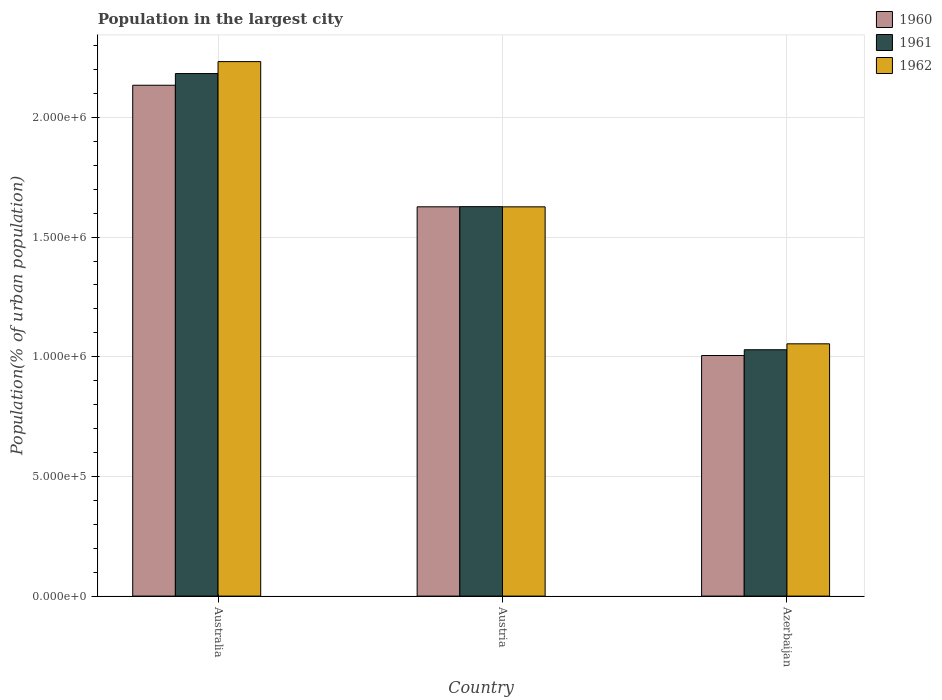Are the number of bars on each tick of the X-axis equal?
Make the answer very short. Yes. How many bars are there on the 3rd tick from the left?
Your answer should be compact. 3. How many bars are there on the 1st tick from the right?
Ensure brevity in your answer.  3. What is the label of the 2nd group of bars from the left?
Offer a terse response. Austria. In how many cases, is the number of bars for a given country not equal to the number of legend labels?
Give a very brief answer. 0. What is the population in the largest city in 1960 in Australia?
Your answer should be very brief. 2.13e+06. Across all countries, what is the maximum population in the largest city in 1962?
Your answer should be compact. 2.23e+06. Across all countries, what is the minimum population in the largest city in 1961?
Ensure brevity in your answer.  1.03e+06. In which country was the population in the largest city in 1961 maximum?
Provide a short and direct response. Australia. In which country was the population in the largest city in 1962 minimum?
Make the answer very short. Azerbaijan. What is the total population in the largest city in 1961 in the graph?
Your answer should be compact. 4.84e+06. What is the difference between the population in the largest city in 1962 in Australia and that in Azerbaijan?
Offer a very short reply. 1.18e+06. What is the difference between the population in the largest city in 1961 in Austria and the population in the largest city in 1962 in Azerbaijan?
Provide a short and direct response. 5.73e+05. What is the average population in the largest city in 1960 per country?
Offer a very short reply. 1.59e+06. What is the difference between the population in the largest city of/in 1960 and population in the largest city of/in 1962 in Azerbaijan?
Offer a terse response. -4.89e+04. What is the ratio of the population in the largest city in 1961 in Australia to that in Austria?
Make the answer very short. 1.34. Is the difference between the population in the largest city in 1960 in Australia and Azerbaijan greater than the difference between the population in the largest city in 1962 in Australia and Azerbaijan?
Give a very brief answer. No. What is the difference between the highest and the second highest population in the largest city in 1961?
Make the answer very short. -5.98e+05. What is the difference between the highest and the lowest population in the largest city in 1962?
Keep it short and to the point. 1.18e+06. In how many countries, is the population in the largest city in 1962 greater than the average population in the largest city in 1962 taken over all countries?
Give a very brief answer. 1. What does the 3rd bar from the left in Azerbaijan represents?
Your answer should be compact. 1962. What does the 1st bar from the right in Austria represents?
Ensure brevity in your answer.  1962. Is it the case that in every country, the sum of the population in the largest city in 1962 and population in the largest city in 1960 is greater than the population in the largest city in 1961?
Offer a very short reply. Yes. Are the values on the major ticks of Y-axis written in scientific E-notation?
Ensure brevity in your answer.  Yes. Does the graph contain any zero values?
Your answer should be very brief. No. Where does the legend appear in the graph?
Offer a terse response. Top right. How many legend labels are there?
Offer a terse response. 3. How are the legend labels stacked?
Provide a short and direct response. Vertical. What is the title of the graph?
Offer a terse response. Population in the largest city. What is the label or title of the X-axis?
Ensure brevity in your answer.  Country. What is the label or title of the Y-axis?
Your answer should be compact. Population(% of urban population). What is the Population(% of urban population) of 1960 in Australia?
Ensure brevity in your answer.  2.13e+06. What is the Population(% of urban population) of 1961 in Australia?
Your response must be concise. 2.18e+06. What is the Population(% of urban population) of 1962 in Australia?
Your answer should be compact. 2.23e+06. What is the Population(% of urban population) in 1960 in Austria?
Offer a very short reply. 1.63e+06. What is the Population(% of urban population) of 1961 in Austria?
Your answer should be compact. 1.63e+06. What is the Population(% of urban population) in 1962 in Austria?
Provide a succinct answer. 1.63e+06. What is the Population(% of urban population) of 1960 in Azerbaijan?
Your answer should be compact. 1.01e+06. What is the Population(% of urban population) of 1961 in Azerbaijan?
Ensure brevity in your answer.  1.03e+06. What is the Population(% of urban population) of 1962 in Azerbaijan?
Provide a short and direct response. 1.05e+06. Across all countries, what is the maximum Population(% of urban population) of 1960?
Offer a terse response. 2.13e+06. Across all countries, what is the maximum Population(% of urban population) of 1961?
Offer a terse response. 2.18e+06. Across all countries, what is the maximum Population(% of urban population) of 1962?
Your response must be concise. 2.23e+06. Across all countries, what is the minimum Population(% of urban population) in 1960?
Make the answer very short. 1.01e+06. Across all countries, what is the minimum Population(% of urban population) in 1961?
Offer a very short reply. 1.03e+06. Across all countries, what is the minimum Population(% of urban population) of 1962?
Ensure brevity in your answer.  1.05e+06. What is the total Population(% of urban population) of 1960 in the graph?
Keep it short and to the point. 4.77e+06. What is the total Population(% of urban population) of 1961 in the graph?
Provide a short and direct response. 4.84e+06. What is the total Population(% of urban population) of 1962 in the graph?
Offer a terse response. 4.91e+06. What is the difference between the Population(% of urban population) of 1960 in Australia and that in Austria?
Your answer should be very brief. 5.08e+05. What is the difference between the Population(% of urban population) in 1961 in Australia and that in Austria?
Keep it short and to the point. 5.56e+05. What is the difference between the Population(% of urban population) of 1962 in Australia and that in Austria?
Provide a succinct answer. 6.07e+05. What is the difference between the Population(% of urban population) in 1960 in Australia and that in Azerbaijan?
Give a very brief answer. 1.13e+06. What is the difference between the Population(% of urban population) of 1961 in Australia and that in Azerbaijan?
Your answer should be very brief. 1.15e+06. What is the difference between the Population(% of urban population) of 1962 in Australia and that in Azerbaijan?
Give a very brief answer. 1.18e+06. What is the difference between the Population(% of urban population) of 1960 in Austria and that in Azerbaijan?
Offer a terse response. 6.21e+05. What is the difference between the Population(% of urban population) in 1961 in Austria and that in Azerbaijan?
Offer a very short reply. 5.98e+05. What is the difference between the Population(% of urban population) of 1962 in Austria and that in Azerbaijan?
Your answer should be very brief. 5.72e+05. What is the difference between the Population(% of urban population) of 1960 in Australia and the Population(% of urban population) of 1961 in Austria?
Your answer should be compact. 5.07e+05. What is the difference between the Population(% of urban population) of 1960 in Australia and the Population(% of urban population) of 1962 in Austria?
Your response must be concise. 5.08e+05. What is the difference between the Population(% of urban population) of 1961 in Australia and the Population(% of urban population) of 1962 in Austria?
Provide a short and direct response. 5.57e+05. What is the difference between the Population(% of urban population) in 1960 in Australia and the Population(% of urban population) in 1961 in Azerbaijan?
Offer a terse response. 1.11e+06. What is the difference between the Population(% of urban population) in 1960 in Australia and the Population(% of urban population) in 1962 in Azerbaijan?
Offer a terse response. 1.08e+06. What is the difference between the Population(% of urban population) in 1961 in Australia and the Population(% of urban population) in 1962 in Azerbaijan?
Ensure brevity in your answer.  1.13e+06. What is the difference between the Population(% of urban population) in 1960 in Austria and the Population(% of urban population) in 1961 in Azerbaijan?
Offer a terse response. 5.97e+05. What is the difference between the Population(% of urban population) of 1960 in Austria and the Population(% of urban population) of 1962 in Azerbaijan?
Ensure brevity in your answer.  5.73e+05. What is the difference between the Population(% of urban population) in 1961 in Austria and the Population(% of urban population) in 1962 in Azerbaijan?
Make the answer very short. 5.73e+05. What is the average Population(% of urban population) of 1960 per country?
Offer a terse response. 1.59e+06. What is the average Population(% of urban population) of 1961 per country?
Make the answer very short. 1.61e+06. What is the average Population(% of urban population) in 1962 per country?
Provide a short and direct response. 1.64e+06. What is the difference between the Population(% of urban population) of 1960 and Population(% of urban population) of 1961 in Australia?
Keep it short and to the point. -4.88e+04. What is the difference between the Population(% of urban population) in 1960 and Population(% of urban population) in 1962 in Australia?
Offer a very short reply. -9.88e+04. What is the difference between the Population(% of urban population) of 1961 and Population(% of urban population) of 1962 in Australia?
Make the answer very short. -4.99e+04. What is the difference between the Population(% of urban population) in 1960 and Population(% of urban population) in 1961 in Austria?
Make the answer very short. -630. What is the difference between the Population(% of urban population) of 1960 and Population(% of urban population) of 1962 in Austria?
Offer a terse response. 129. What is the difference between the Population(% of urban population) of 1961 and Population(% of urban population) of 1962 in Austria?
Your answer should be very brief. 759. What is the difference between the Population(% of urban population) in 1960 and Population(% of urban population) in 1961 in Azerbaijan?
Provide a short and direct response. -2.41e+04. What is the difference between the Population(% of urban population) in 1960 and Population(% of urban population) in 1962 in Azerbaijan?
Your answer should be very brief. -4.89e+04. What is the difference between the Population(% of urban population) in 1961 and Population(% of urban population) in 1962 in Azerbaijan?
Offer a terse response. -2.47e+04. What is the ratio of the Population(% of urban population) in 1960 in Australia to that in Austria?
Give a very brief answer. 1.31. What is the ratio of the Population(% of urban population) in 1961 in Australia to that in Austria?
Offer a very short reply. 1.34. What is the ratio of the Population(% of urban population) of 1962 in Australia to that in Austria?
Make the answer very short. 1.37. What is the ratio of the Population(% of urban population) in 1960 in Australia to that in Azerbaijan?
Your answer should be compact. 2.12. What is the ratio of the Population(% of urban population) in 1961 in Australia to that in Azerbaijan?
Your response must be concise. 2.12. What is the ratio of the Population(% of urban population) in 1962 in Australia to that in Azerbaijan?
Ensure brevity in your answer.  2.12. What is the ratio of the Population(% of urban population) of 1960 in Austria to that in Azerbaijan?
Ensure brevity in your answer.  1.62. What is the ratio of the Population(% of urban population) in 1961 in Austria to that in Azerbaijan?
Your answer should be very brief. 1.58. What is the ratio of the Population(% of urban population) in 1962 in Austria to that in Azerbaijan?
Provide a succinct answer. 1.54. What is the difference between the highest and the second highest Population(% of urban population) of 1960?
Offer a very short reply. 5.08e+05. What is the difference between the highest and the second highest Population(% of urban population) of 1961?
Your response must be concise. 5.56e+05. What is the difference between the highest and the second highest Population(% of urban population) in 1962?
Offer a very short reply. 6.07e+05. What is the difference between the highest and the lowest Population(% of urban population) in 1960?
Your answer should be compact. 1.13e+06. What is the difference between the highest and the lowest Population(% of urban population) of 1961?
Keep it short and to the point. 1.15e+06. What is the difference between the highest and the lowest Population(% of urban population) of 1962?
Ensure brevity in your answer.  1.18e+06. 